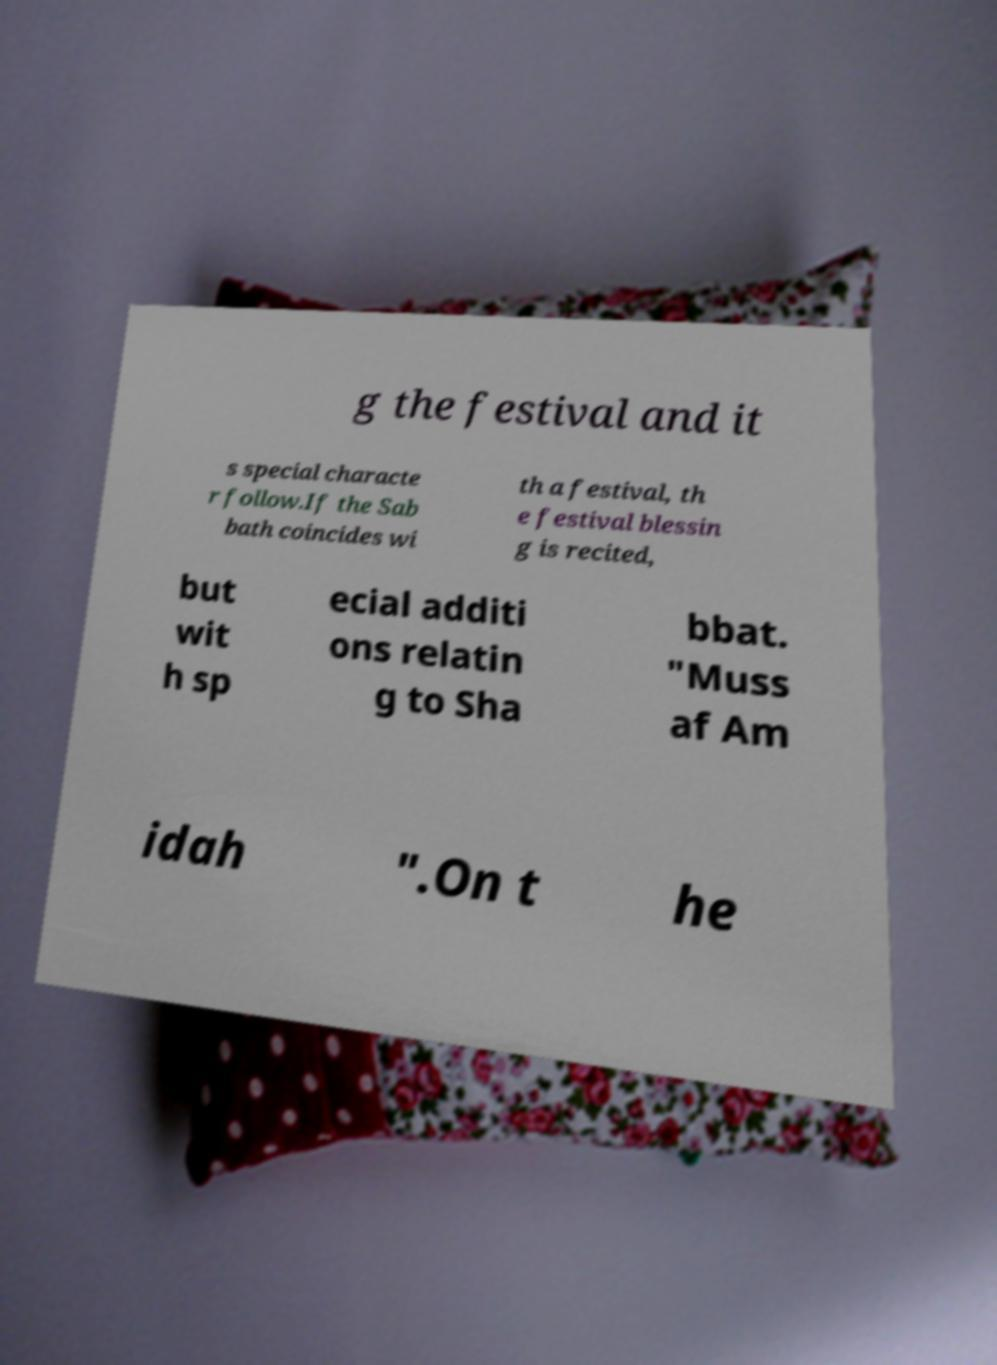Could you assist in decoding the text presented in this image and type it out clearly? g the festival and it s special characte r follow.If the Sab bath coincides wi th a festival, th e festival blessin g is recited, but wit h sp ecial additi ons relatin g to Sha bbat. "Muss af Am idah ".On t he 